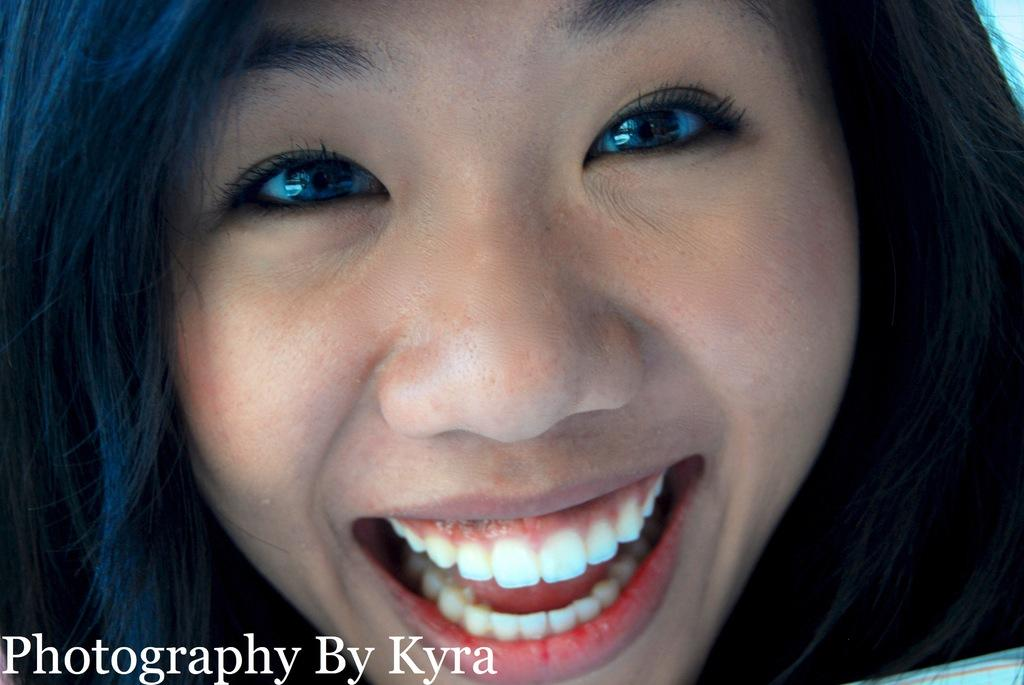What is the main subject of the image? The main subject of the image is a person's face. What expression does the person have in the image? The person is smiling in the image. What type of snail can be seen crawling on the person's face in the image? There is no snail present on the person's face in the image. What type of hearing aid is the person wearing in the image? The image does not show the person wearing a hearing aid. 